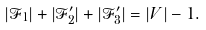<formula> <loc_0><loc_0><loc_500><loc_500>| \mathcal { F } _ { 1 } | + | \mathcal { F } ^ { \prime } _ { 2 } | + | \mathcal { F } ^ { \prime } _ { 3 } | = | V | - 1 .</formula> 